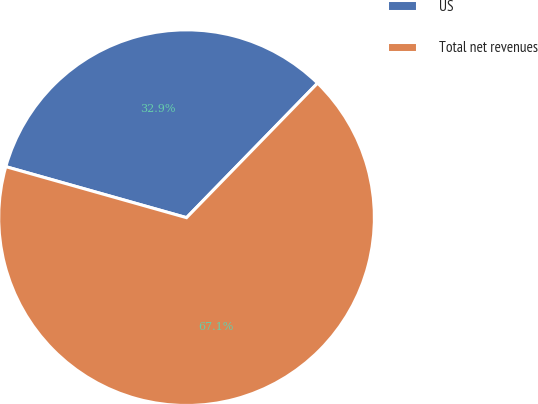Convert chart. <chart><loc_0><loc_0><loc_500><loc_500><pie_chart><fcel>US<fcel>Total net revenues<nl><fcel>32.91%<fcel>67.09%<nl></chart> 